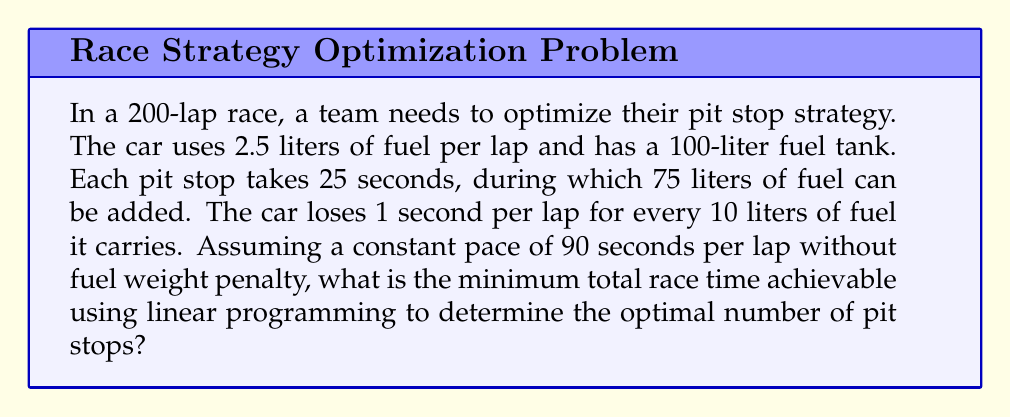Solve this math problem. Let's approach this step-by-step using linear programming:

1) Define variables:
   $x$ = number of pit stops
   $y$ = average amount of fuel carried per lap

2) Objective function (total race time):
   $T = 200(90 + 0.1y) + 25x$ (lap time + fuel weight penalty + pit stop time)

3) Constraints:
   a) Fuel usage: $200 \cdot 2.5 = 75x + 100$ (total fuel used = fuel added in pits + initial fuel)
   b) Average fuel carried: $y = 50 + \frac{37.5x}{200}$ (initial 100L / 2 + half of fuel added in pits)

4) Substituting (3b) into the objective function:
   $T = 200(90 + 0.1(50 + \frac{37.5x}{200})) + 25x$
   $T = 18000 + 1000 + 3.75x + 25x$
   $T = 19000 + 28.75x$

5) From (3a), we can express $x$ in terms of total laps:
   $x = \frac{200 \cdot 2.5 - 100}{75} = \frac{400}{75} \approx 5.33$

6) Since $x$ must be an integer, we need to check both $x = 5$ and $x = 6$:

   For $x = 5$: $T = 19000 + 28.75(5) = 19143.75$ seconds
   For $x = 6$: $T = 19000 + 28.75(6) = 19172.50$ seconds

Therefore, the optimal strategy is to make 5 pit stops.
Answer: 19143.75 seconds 